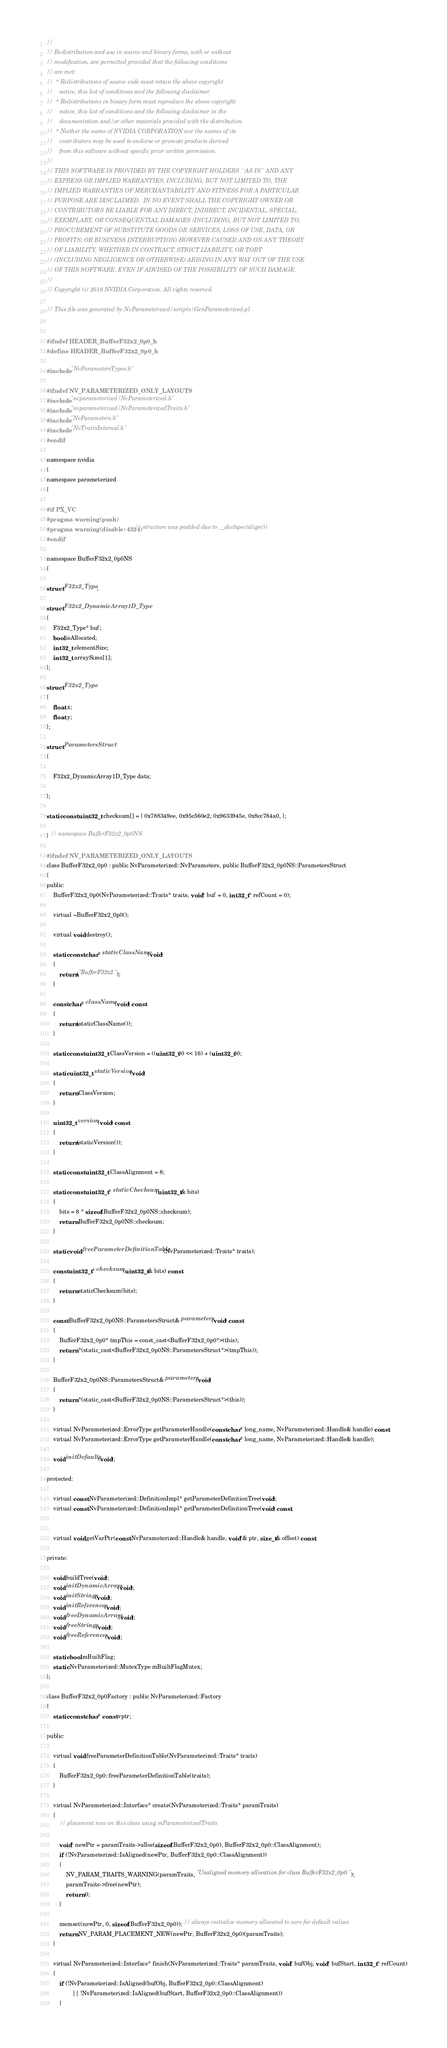<code> <loc_0><loc_0><loc_500><loc_500><_C_>//
// Redistribution and use in source and binary forms, with or without
// modification, are permitted provided that the following conditions
// are met:
//  * Redistributions of source code must retain the above copyright
//    notice, this list of conditions and the following disclaimer.
//  * Redistributions in binary form must reproduce the above copyright
//    notice, this list of conditions and the following disclaimer in the
//    documentation and/or other materials provided with the distribution.
//  * Neither the name of NVIDIA CORPORATION nor the names of its
//    contributors may be used to endorse or promote products derived
//    from this software without specific prior written permission.
//
// THIS SOFTWARE IS PROVIDED BY THE COPYRIGHT HOLDERS ``AS IS'' AND ANY
// EXPRESS OR IMPLIED WARRANTIES, INCLUDING, BUT NOT LIMITED TO, THE
// IMPLIED WARRANTIES OF MERCHANTABILITY AND FITNESS FOR A PARTICULAR
// PURPOSE ARE DISCLAIMED.  IN NO EVENT SHALL THE COPYRIGHT OWNER OR
// CONTRIBUTORS BE LIABLE FOR ANY DIRECT, INDIRECT, INCIDENTAL, SPECIAL,
// EXEMPLARY, OR CONSEQUENTIAL DAMAGES (INCLUDING, BUT NOT LIMITED TO,
// PROCUREMENT OF SUBSTITUTE GOODS OR SERVICES; LOSS OF USE, DATA, OR
// PROFITS; OR BUSINESS INTERRUPTION) HOWEVER CAUSED AND ON ANY THEORY
// OF LIABILITY, WHETHER IN CONTRACT, STRICT LIABILITY, OR TORT
// (INCLUDING NEGLIGENCE OR OTHERWISE) ARISING IN ANY WAY OUT OF THE USE
// OF THIS SOFTWARE, EVEN IF ADVISED OF THE POSSIBILITY OF SUCH DAMAGE.
//
// Copyright (c) 2018 NVIDIA Corporation. All rights reserved.

// This file was generated by NvParameterized/scripts/GenParameterized.pl


#ifndef HEADER_BufferF32x2_0p0_h
#define HEADER_BufferF32x2_0p0_h

#include "NvParametersTypes.h"

#ifndef NV_PARAMETERIZED_ONLY_LAYOUTS
#include "nvparameterized/NvParameterized.h"
#include "nvparameterized/NvParameterizedTraits.h"
#include "NvParameters.h"
#include "NvTraitsInternal.h"
#endif

namespace nvidia
{
namespace parameterized
{

#if PX_VC
#pragma warning(push)
#pragma warning(disable: 4324) // structure was padded due to __declspec(align())
#endif

namespace BufferF32x2_0p0NS
{

struct F32x2_Type;

struct F32x2_DynamicArray1D_Type
{
	F32x2_Type* buf;
	bool isAllocated;
	int32_t elementSize;
	int32_t arraySizes[1];
};

struct F32x2_Type
{
	float x;
	float y;
};

struct ParametersStruct
{

	F32x2_DynamicArray1D_Type data;

};

static const uint32_t checksum[] = { 0x788349ee, 0x95c560e2, 0x9633945e, 0x8cc784a0, };

} // namespace BufferF32x2_0p0NS

#ifndef NV_PARAMETERIZED_ONLY_LAYOUTS
class BufferF32x2_0p0 : public NvParameterized::NvParameters, public BufferF32x2_0p0NS::ParametersStruct
{
public:
	BufferF32x2_0p0(NvParameterized::Traits* traits, void* buf = 0, int32_t* refCount = 0);

	virtual ~BufferF32x2_0p0();

	virtual void destroy();

	static const char* staticClassName(void)
	{
		return("BufferF32x2");
	}

	const char* className(void) const
	{
		return(staticClassName());
	}

	static const uint32_t ClassVersion = ((uint32_t)0 << 16) + (uint32_t)0;

	static uint32_t staticVersion(void)
	{
		return ClassVersion;
	}

	uint32_t version(void) const
	{
		return(staticVersion());
	}

	static const uint32_t ClassAlignment = 8;

	static const uint32_t* staticChecksum(uint32_t& bits)
	{
		bits = 8 * sizeof(BufferF32x2_0p0NS::checksum);
		return BufferF32x2_0p0NS::checksum;
	}

	static void freeParameterDefinitionTable(NvParameterized::Traits* traits);

	const uint32_t* checksum(uint32_t& bits) const
	{
		return staticChecksum(bits);
	}

	const BufferF32x2_0p0NS::ParametersStruct& parameters(void) const
	{
		BufferF32x2_0p0* tmpThis = const_cast<BufferF32x2_0p0*>(this);
		return *(static_cast<BufferF32x2_0p0NS::ParametersStruct*>(tmpThis));
	}

	BufferF32x2_0p0NS::ParametersStruct& parameters(void)
	{
		return *(static_cast<BufferF32x2_0p0NS::ParametersStruct*>(this));
	}

	virtual NvParameterized::ErrorType getParameterHandle(const char* long_name, NvParameterized::Handle& handle) const;
	virtual NvParameterized::ErrorType getParameterHandle(const char* long_name, NvParameterized::Handle& handle);

	void initDefaults(void);

protected:

	virtual const NvParameterized::DefinitionImpl* getParameterDefinitionTree(void);
	virtual const NvParameterized::DefinitionImpl* getParameterDefinitionTree(void) const;


	virtual void getVarPtr(const NvParameterized::Handle& handle, void*& ptr, size_t& offset) const;

private:

	void buildTree(void);
	void initDynamicArrays(void);
	void initStrings(void);
	void initReferences(void);
	void freeDynamicArrays(void);
	void freeStrings(void);
	void freeReferences(void);

	static bool mBuiltFlag;
	static NvParameterized::MutexType mBuiltFlagMutex;
};

class BufferF32x2_0p0Factory : public NvParameterized::Factory
{
	static const char* const vptr;

public:

	virtual void freeParameterDefinitionTable(NvParameterized::Traits* traits)
	{
		BufferF32x2_0p0::freeParameterDefinitionTable(traits);
	}

	virtual NvParameterized::Interface* create(NvParameterized::Traits* paramTraits)
	{
		// placement new on this class using mParameterizedTraits

		void* newPtr = paramTraits->alloc(sizeof(BufferF32x2_0p0), BufferF32x2_0p0::ClassAlignment);
		if (!NvParameterized::IsAligned(newPtr, BufferF32x2_0p0::ClassAlignment))
		{
			NV_PARAM_TRAITS_WARNING(paramTraits, "Unaligned memory allocation for class BufferF32x2_0p0");
			paramTraits->free(newPtr);
			return 0;
		}

		memset(newPtr, 0, sizeof(BufferF32x2_0p0)); // always initialize memory allocated to zero for default values
		return NV_PARAM_PLACEMENT_NEW(newPtr, BufferF32x2_0p0)(paramTraits);
	}

	virtual NvParameterized::Interface* finish(NvParameterized::Traits* paramTraits, void* bufObj, void* bufStart, int32_t* refCount)
	{
		if (!NvParameterized::IsAligned(bufObj, BufferF32x2_0p0::ClassAlignment)
		        || !NvParameterized::IsAligned(bufStart, BufferF32x2_0p0::ClassAlignment))
		{</code> 